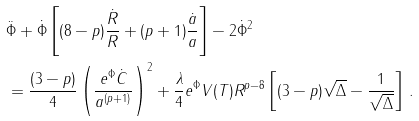<formula> <loc_0><loc_0><loc_500><loc_500>& { \ddot { \Phi } } + { \dot { \Phi } } \left [ ( 8 - p ) { \frac { { \dot { R } } } { R } } + ( p + 1 ) { \frac { { \dot { a } } } { a } } \right ] - 2 { \dot { \Phi } } ^ { 2 } \\ & = { \frac { ( 3 - p ) } { 4 } } \left ( { \frac { e ^ { \Phi } { \dot { C } } } { a ^ { ( p + 1 ) } } } \right ) ^ { 2 } + { \frac { \lambda } { 4 } } e ^ { \Phi } V ( T ) R ^ { p - 8 } \left [ ( 3 - p ) \sqrt { \Delta } - { \frac { 1 } { \sqrt { \Delta } } } \right ] \, .</formula> 